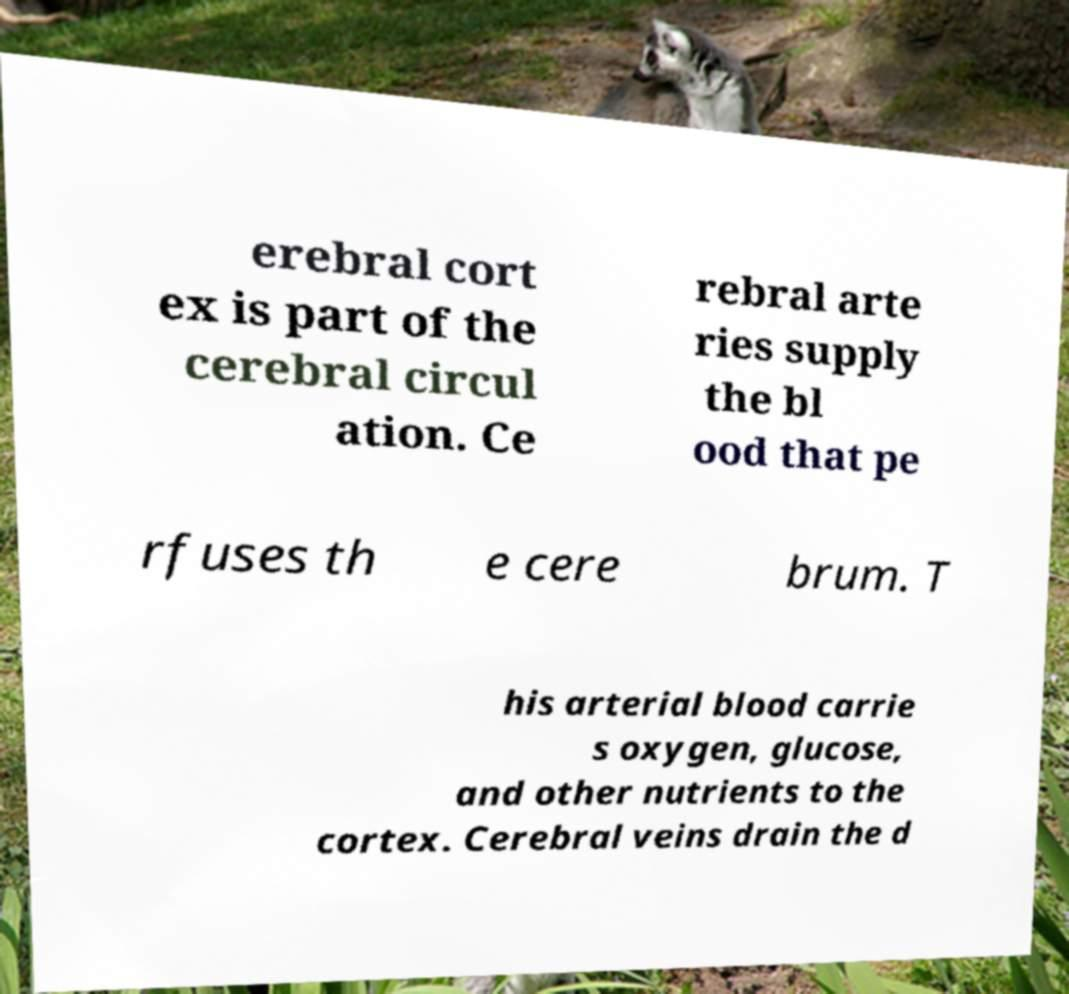Can you accurately transcribe the text from the provided image for me? erebral cort ex is part of the cerebral circul ation. Ce rebral arte ries supply the bl ood that pe rfuses th e cere brum. T his arterial blood carrie s oxygen, glucose, and other nutrients to the cortex. Cerebral veins drain the d 